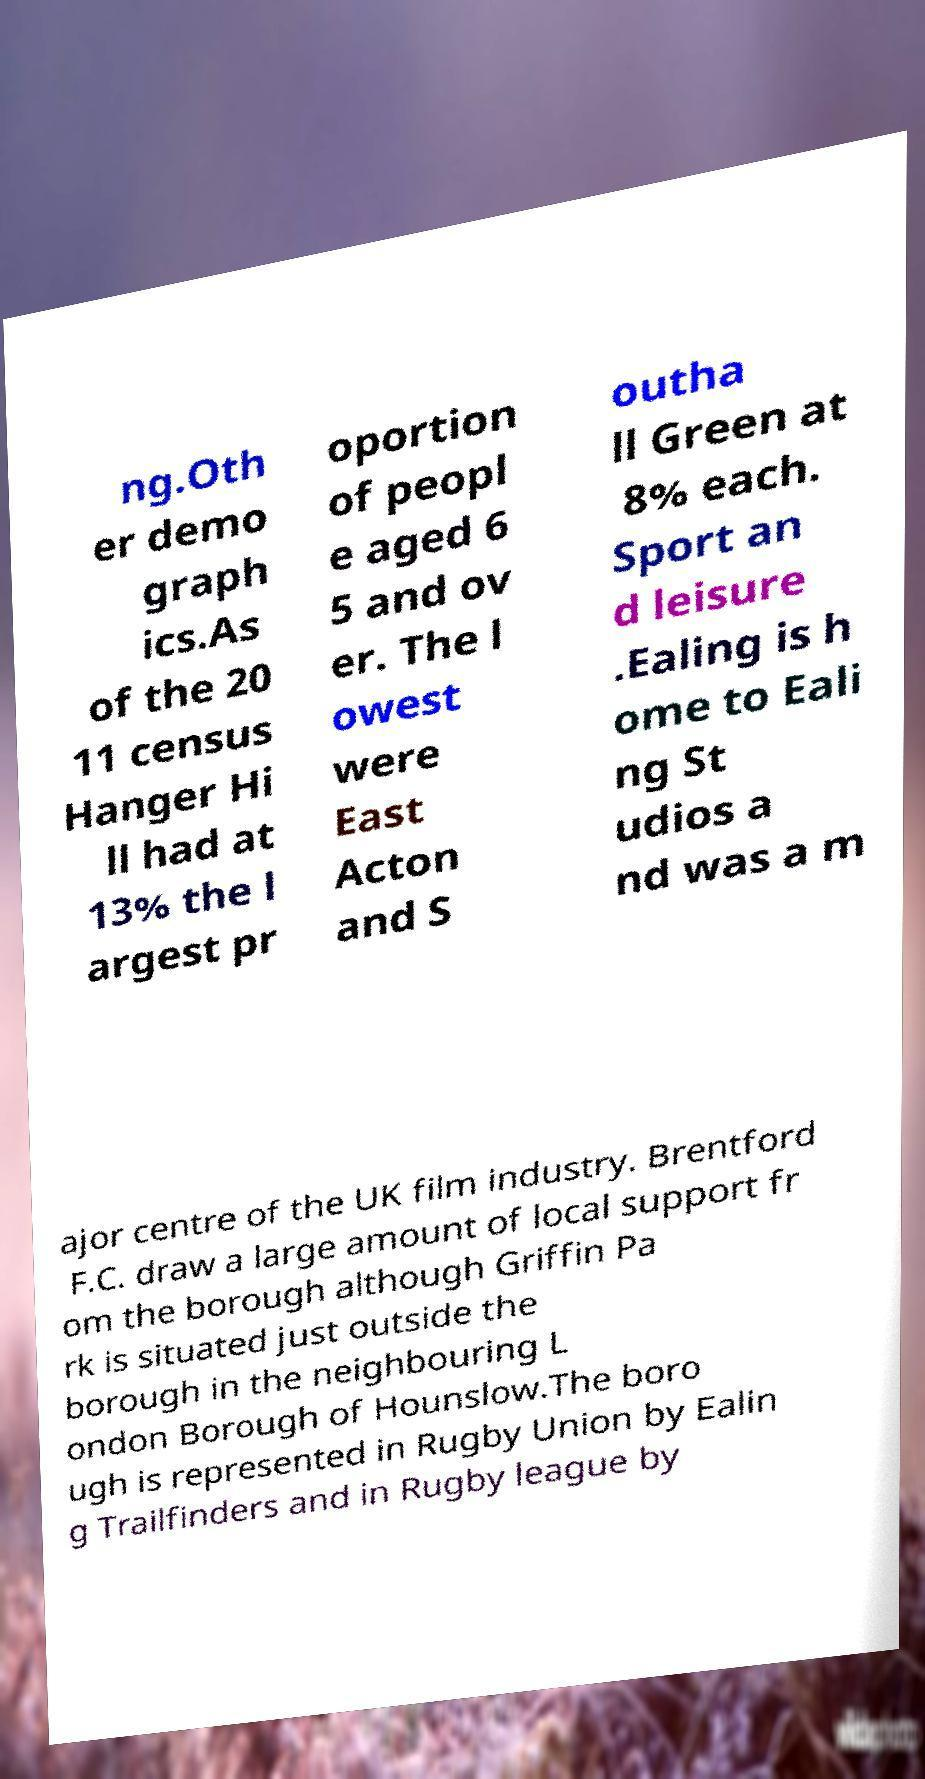Can you read and provide the text displayed in the image?This photo seems to have some interesting text. Can you extract and type it out for me? ng.Oth er demo graph ics.As of the 20 11 census Hanger Hi ll had at 13% the l argest pr oportion of peopl e aged 6 5 and ov er. The l owest were East Acton and S outha ll Green at 8% each. Sport an d leisure .Ealing is h ome to Eali ng St udios a nd was a m ajor centre of the UK film industry. Brentford F.C. draw a large amount of local support fr om the borough although Griffin Pa rk is situated just outside the borough in the neighbouring L ondon Borough of Hounslow.The boro ugh is represented in Rugby Union by Ealin g Trailfinders and in Rugby league by 